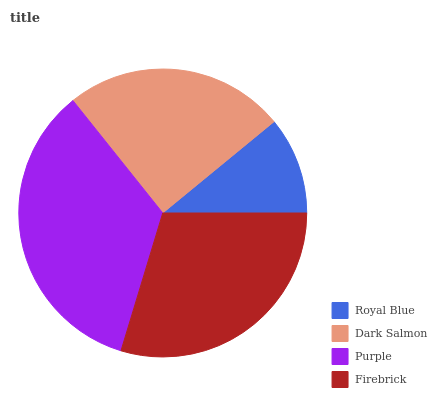Is Royal Blue the minimum?
Answer yes or no. Yes. Is Purple the maximum?
Answer yes or no. Yes. Is Dark Salmon the minimum?
Answer yes or no. No. Is Dark Salmon the maximum?
Answer yes or no. No. Is Dark Salmon greater than Royal Blue?
Answer yes or no. Yes. Is Royal Blue less than Dark Salmon?
Answer yes or no. Yes. Is Royal Blue greater than Dark Salmon?
Answer yes or no. No. Is Dark Salmon less than Royal Blue?
Answer yes or no. No. Is Firebrick the high median?
Answer yes or no. Yes. Is Dark Salmon the low median?
Answer yes or no. Yes. Is Purple the high median?
Answer yes or no. No. Is Royal Blue the low median?
Answer yes or no. No. 